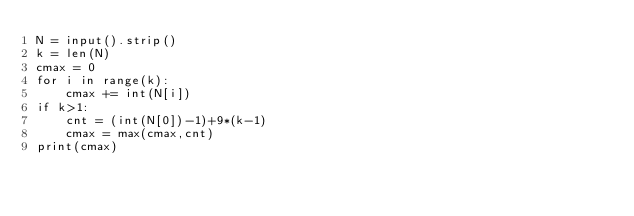Convert code to text. <code><loc_0><loc_0><loc_500><loc_500><_Python_>N = input().strip()
k = len(N)
cmax = 0
for i in range(k):
    cmax += int(N[i])
if k>1:
    cnt = (int(N[0])-1)+9*(k-1)
    cmax = max(cmax,cnt)
print(cmax)</code> 